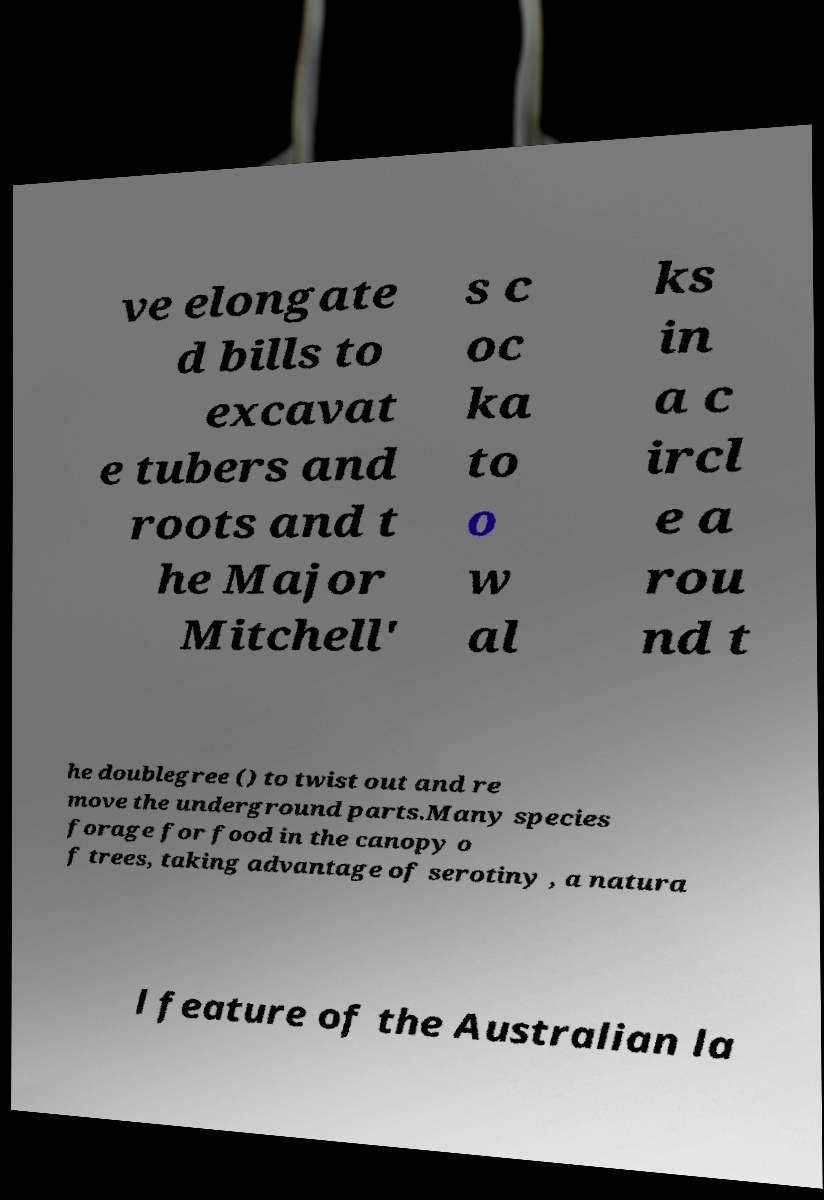Could you assist in decoding the text presented in this image and type it out clearly? ve elongate d bills to excavat e tubers and roots and t he Major Mitchell' s c oc ka to o w al ks in a c ircl e a rou nd t he doublegree () to twist out and re move the underground parts.Many species forage for food in the canopy o f trees, taking advantage of serotiny , a natura l feature of the Australian la 